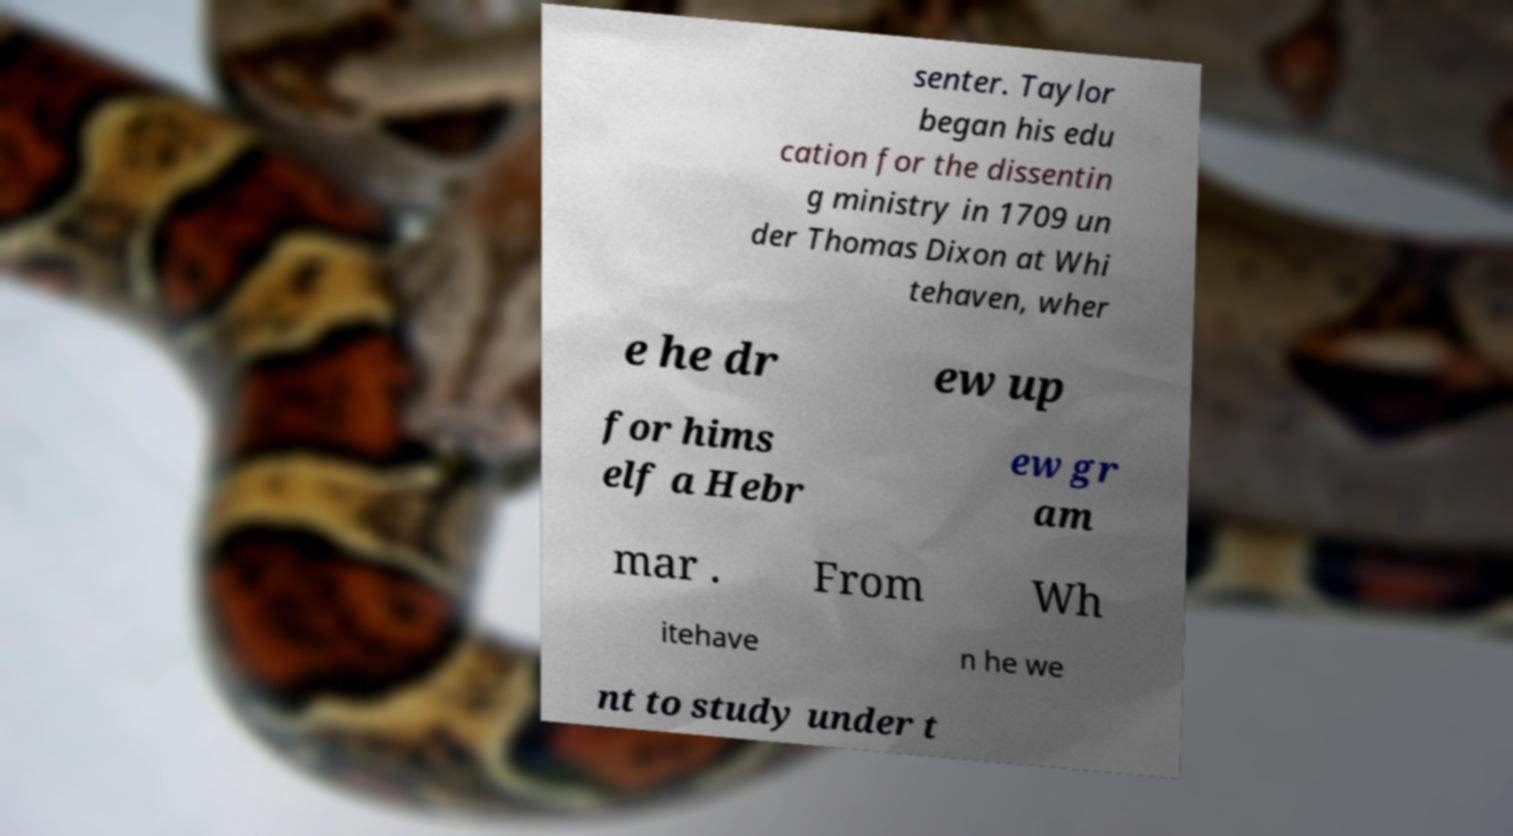Please identify and transcribe the text found in this image. senter. Taylor began his edu cation for the dissentin g ministry in 1709 un der Thomas Dixon at Whi tehaven, wher e he dr ew up for hims elf a Hebr ew gr am mar . From Wh itehave n he we nt to study under t 